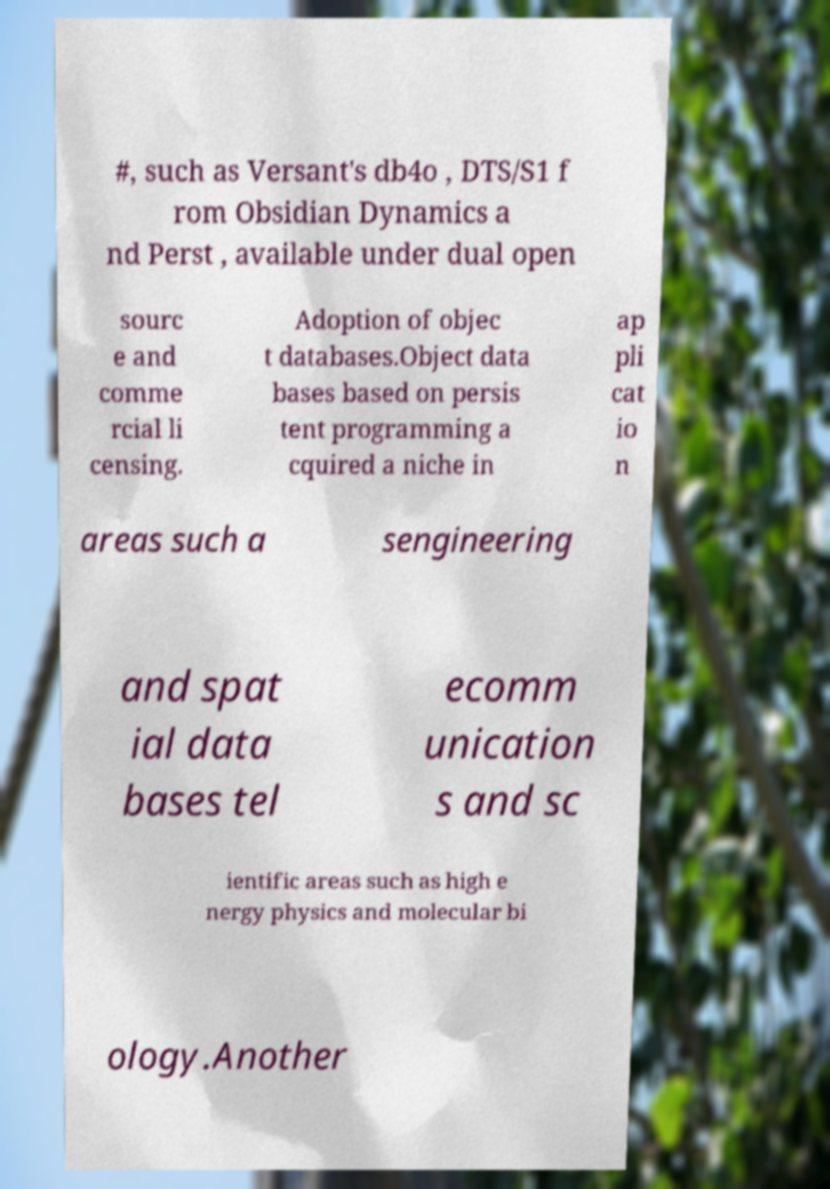Please identify and transcribe the text found in this image. #, such as Versant's db4o , DTS/S1 f rom Obsidian Dynamics a nd Perst , available under dual open sourc e and comme rcial li censing. Adoption of objec t databases.Object data bases based on persis tent programming a cquired a niche in ap pli cat io n areas such a sengineering and spat ial data bases tel ecomm unication s and sc ientific areas such as high e nergy physics and molecular bi ology.Another 